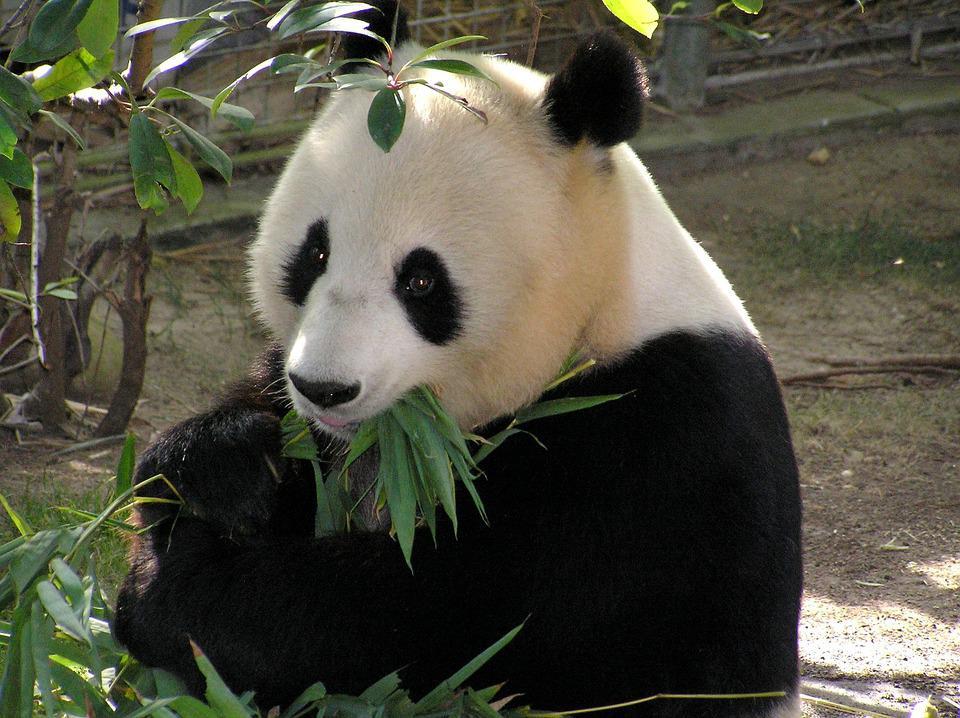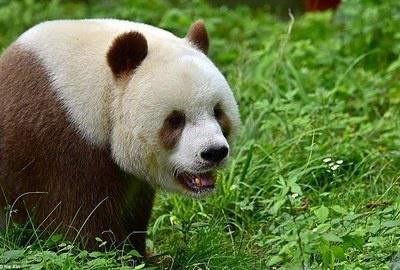The first image is the image on the left, the second image is the image on the right. Considering the images on both sides, is "The left image contains a panda chewing on food." valid? Answer yes or no. Yes. The first image is the image on the left, the second image is the image on the right. Examine the images to the left and right. Is the description "An image shows a brown and white panda surrounded by foliage." accurate? Answer yes or no. Yes. 